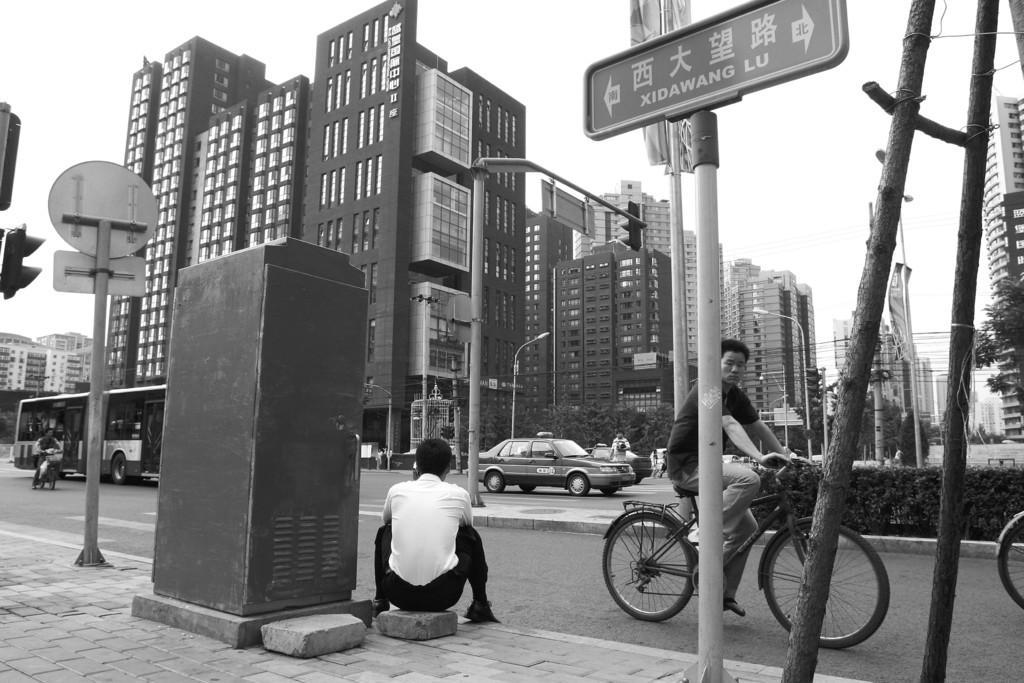Please provide a concise description of this image. In this image I can see few people where one man is cycling a cycle and another one is sitting. I can also see few buildings, few sign boards and few vehicles. Here I can see a tree. 